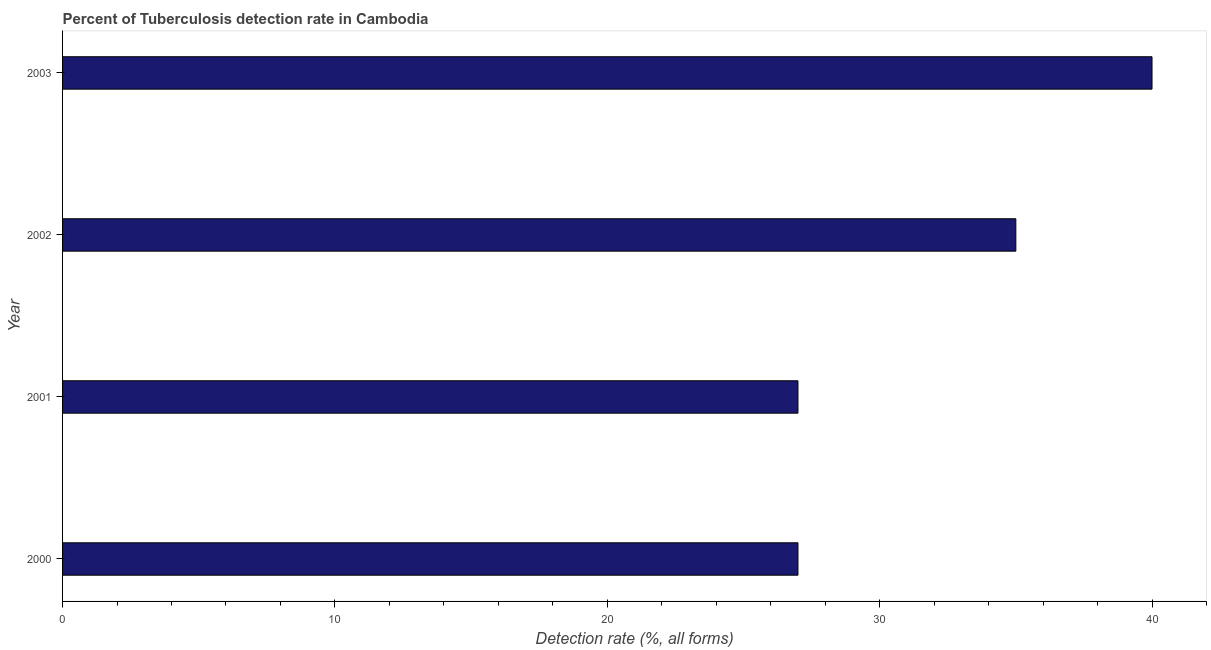Does the graph contain any zero values?
Your response must be concise. No. What is the title of the graph?
Make the answer very short. Percent of Tuberculosis detection rate in Cambodia. What is the label or title of the X-axis?
Your answer should be very brief. Detection rate (%, all forms). What is the detection rate of tuberculosis in 2001?
Give a very brief answer. 27. Across all years, what is the minimum detection rate of tuberculosis?
Ensure brevity in your answer.  27. In which year was the detection rate of tuberculosis maximum?
Offer a terse response. 2003. In which year was the detection rate of tuberculosis minimum?
Provide a succinct answer. 2000. What is the sum of the detection rate of tuberculosis?
Offer a terse response. 129. What is the difference between the detection rate of tuberculosis in 2002 and 2003?
Give a very brief answer. -5. What is the median detection rate of tuberculosis?
Keep it short and to the point. 31. In how many years, is the detection rate of tuberculosis greater than 2 %?
Your answer should be compact. 4. Do a majority of the years between 2003 and 2001 (inclusive) have detection rate of tuberculosis greater than 22 %?
Your answer should be compact. Yes. What is the ratio of the detection rate of tuberculosis in 2001 to that in 2002?
Your answer should be compact. 0.77. Is the difference between the detection rate of tuberculosis in 2002 and 2003 greater than the difference between any two years?
Offer a terse response. No. Is the sum of the detection rate of tuberculosis in 2000 and 2003 greater than the maximum detection rate of tuberculosis across all years?
Offer a very short reply. Yes. How many bars are there?
Your answer should be very brief. 4. How many years are there in the graph?
Ensure brevity in your answer.  4. What is the difference between two consecutive major ticks on the X-axis?
Provide a short and direct response. 10. What is the Detection rate (%, all forms) of 2001?
Your answer should be compact. 27. What is the Detection rate (%, all forms) in 2002?
Keep it short and to the point. 35. What is the difference between the Detection rate (%, all forms) in 2000 and 2003?
Give a very brief answer. -13. What is the difference between the Detection rate (%, all forms) in 2001 and 2002?
Offer a very short reply. -8. What is the difference between the Detection rate (%, all forms) in 2001 and 2003?
Provide a succinct answer. -13. What is the ratio of the Detection rate (%, all forms) in 2000 to that in 2001?
Give a very brief answer. 1. What is the ratio of the Detection rate (%, all forms) in 2000 to that in 2002?
Your answer should be compact. 0.77. What is the ratio of the Detection rate (%, all forms) in 2000 to that in 2003?
Provide a succinct answer. 0.68. What is the ratio of the Detection rate (%, all forms) in 2001 to that in 2002?
Give a very brief answer. 0.77. What is the ratio of the Detection rate (%, all forms) in 2001 to that in 2003?
Your answer should be very brief. 0.68. What is the ratio of the Detection rate (%, all forms) in 2002 to that in 2003?
Ensure brevity in your answer.  0.88. 